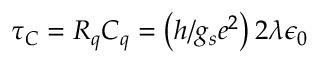Convert formula to latex. <formula><loc_0><loc_0><loc_500><loc_500>\tau _ { C } = R _ { q } C _ { q } = \left ( h / g _ { s } e ^ { 2 } \right ) 2 \lambda \epsilon _ { 0 }</formula> 